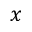Convert formula to latex. <formula><loc_0><loc_0><loc_500><loc_500>x</formula> 